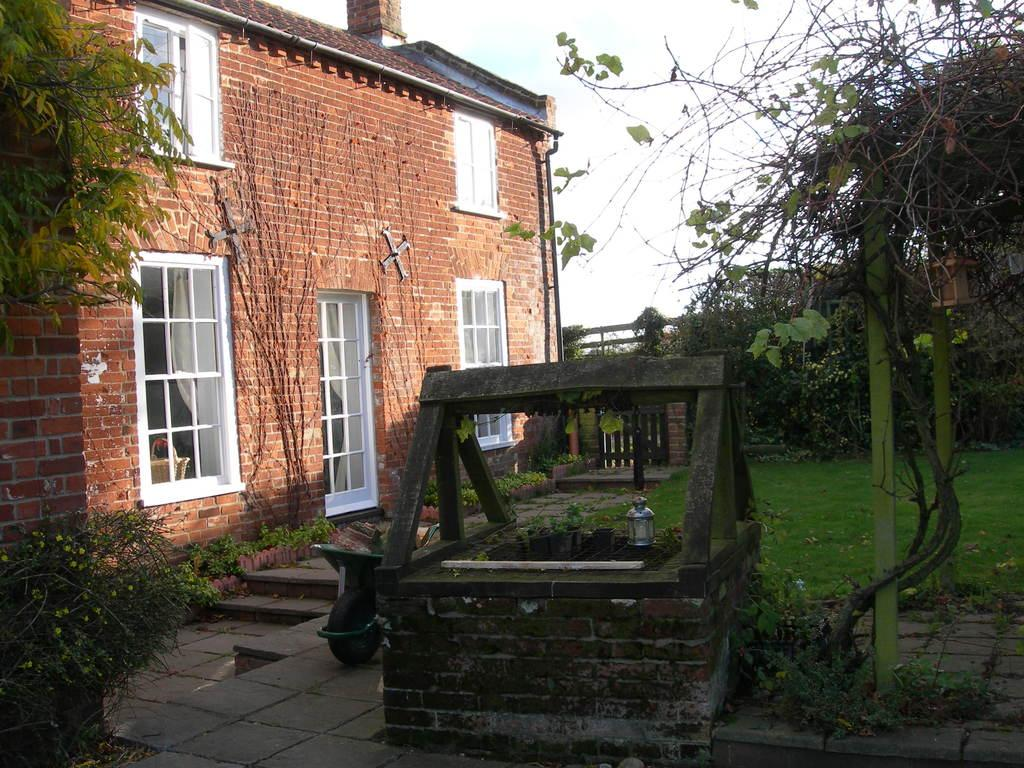What type of structure is present in the picture? There is a building in the picture. What feature can be seen on the building? The building has windows. What is another object present in the picture? There is a well in the picture. What type of natural elements can be seen in the picture? There are plants and trees in the picture. What is the condition of the sky in the picture? The sky is clear in the picture. What color is the ink used to write on the box in the picture? There is no box or ink present in the picture; it features a building, a well, plants, trees, and a clear sky. What is the tongue of the creature doing in the picture? There is no creature or tongue present in the picture. 